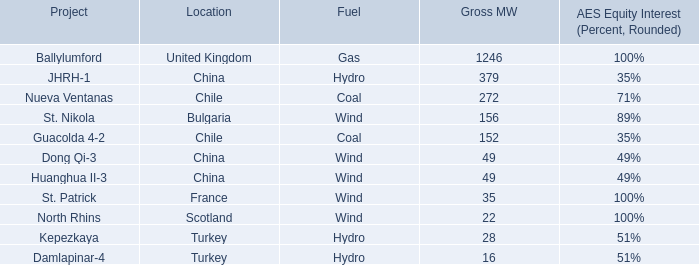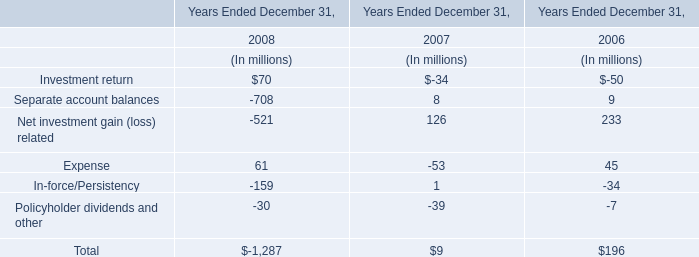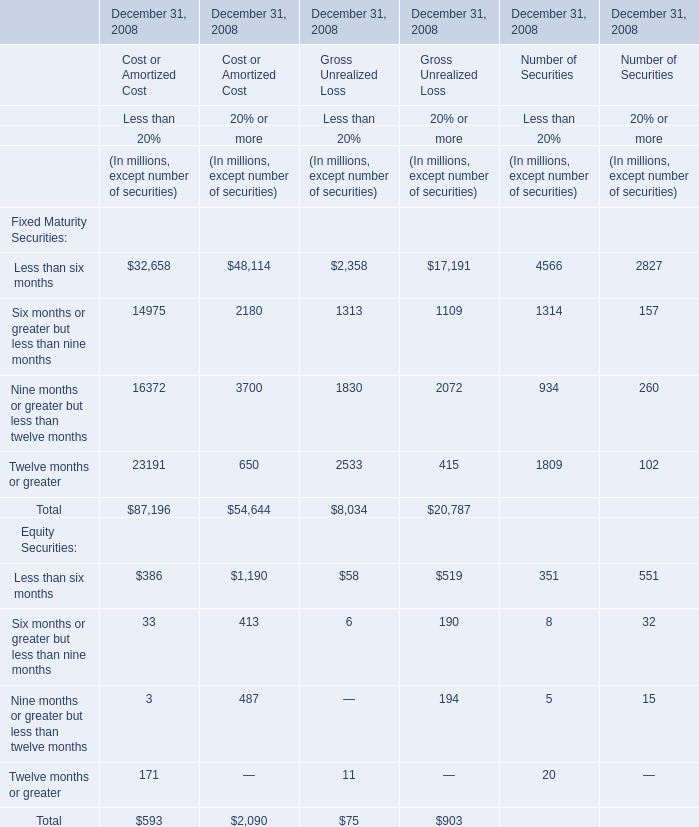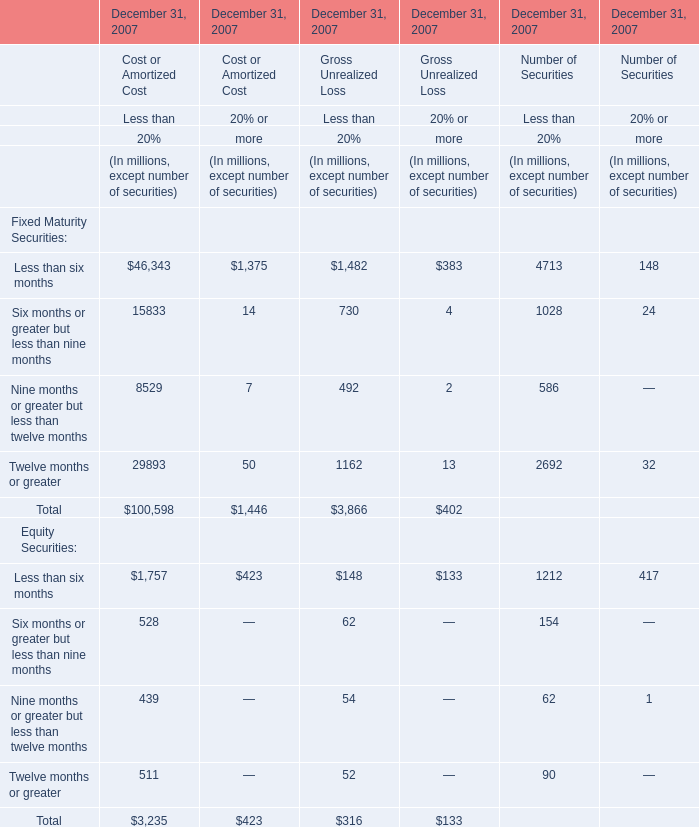what percentage of mw from acquired or commenced commercial operations in 2010 were due to ballylumford in the united kingdom? 
Computations: (1246 / 2404)
Answer: 0.5183. 